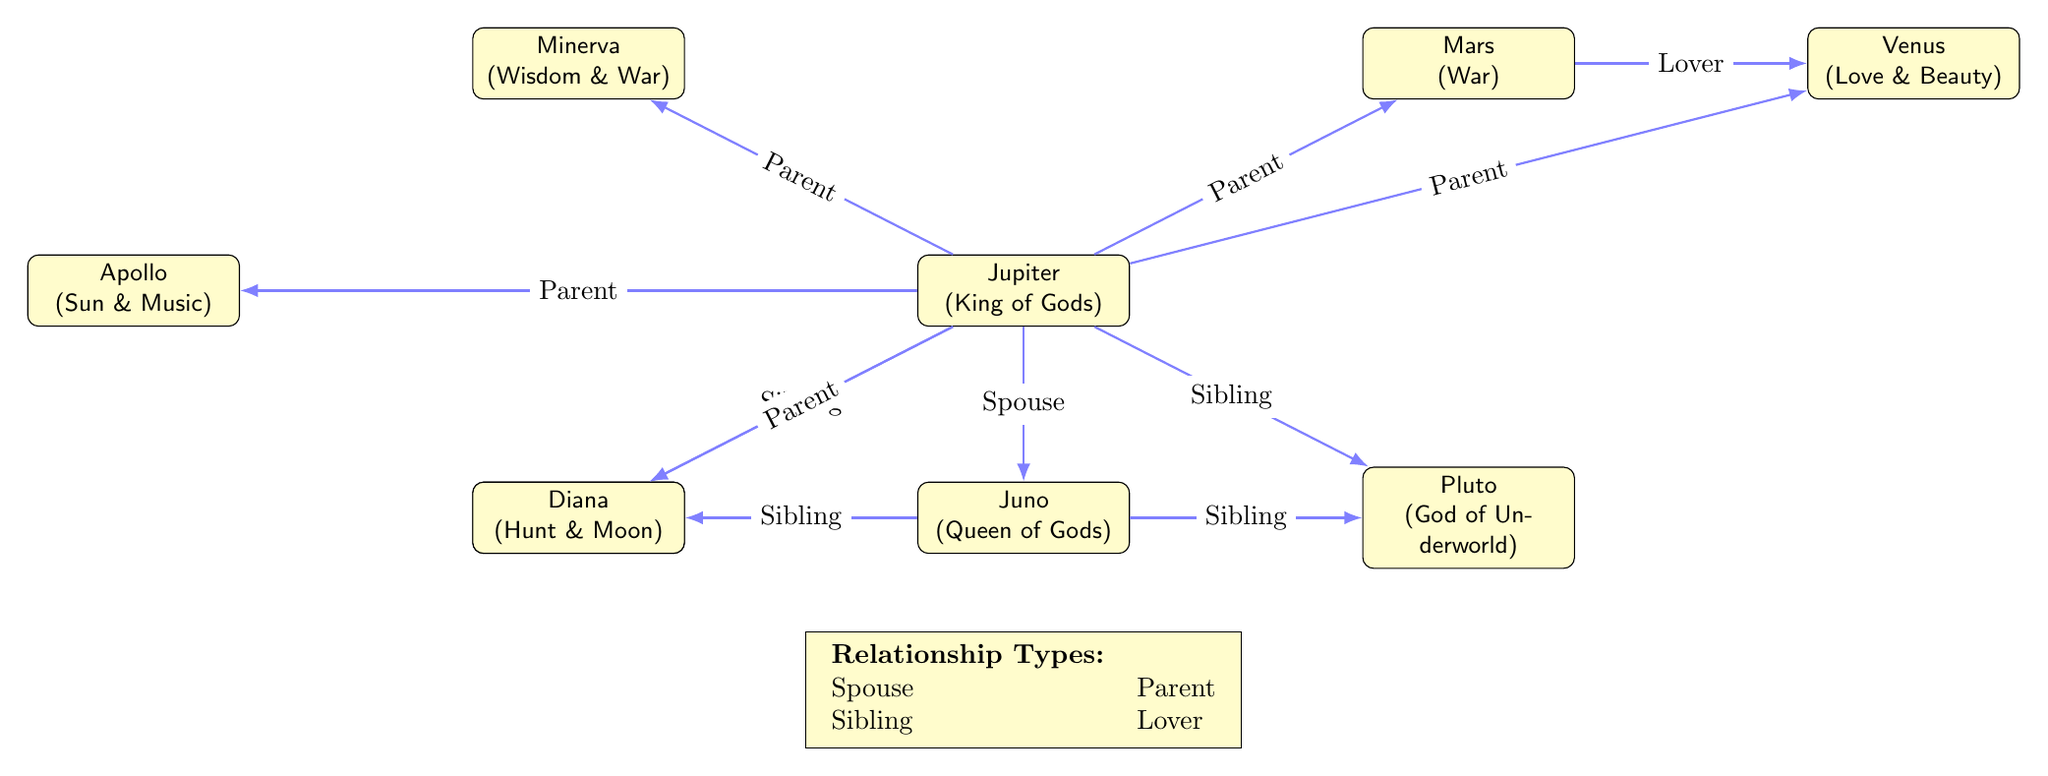What is the relationship between Jupiter and Juno? In the diagram, the line connecting Jupiter and Juno is labeled "Spouse," indicating that they are married to each other.
Answer: Spouse How many deities are represented in the diagram? By counting the nodes labeled as deities in the diagram, including Jupiter, Juno, Neptune, Pluto, Minerva, Mars, Venus, Apollo, and Diana, we find there are a total of 9 deities.
Answer: 9 Who are Jupiter's siblings? From the diagram, Jupiter has two siblings: Neptune and Pluto, as indicated by the lines labeled "Sibling" that connect him to both.
Answer: Neptune, Pluto What type of relationship exists between Mars and Venus? The line between Mars and Venus is labeled "Lover," which identifies the nature of their relationship as romantic.
Answer: Lover How many children does Jupiter have? The diagram shows five lines leading from Jupiter to different deities, each labeled "Parent," indicating he has five children: Minerva, Mars, Venus, Apollo, and Diana.
Answer: 5 What is the relationship type between Juno and Pluto? In the diagram, Juno is connected to Pluto with a line labeled "Sibling," which establishes that they are siblings in Roman mythology.
Answer: Sibling Which deity is the king of gods? From the diagram, Jupiter is indicated as the "King of Gods," identifying him as the most powerful deity.
Answer: Jupiter Which deity is associated with love and beauty? Venus is specifically labeled in the diagram as the "Goddess of Love and Beauty," making her the deity associated with that aspect.
Answer: Venus What is the total number of sibling relationships depicted in the diagram? By examining the provided relationships, there are four sibling connections depicted: Jupiter-Neptune, Jupiter-Pluto, Juno-Neptune, and Juno-Pluto, which sum up to four sibling relationships in total.
Answer: 4 